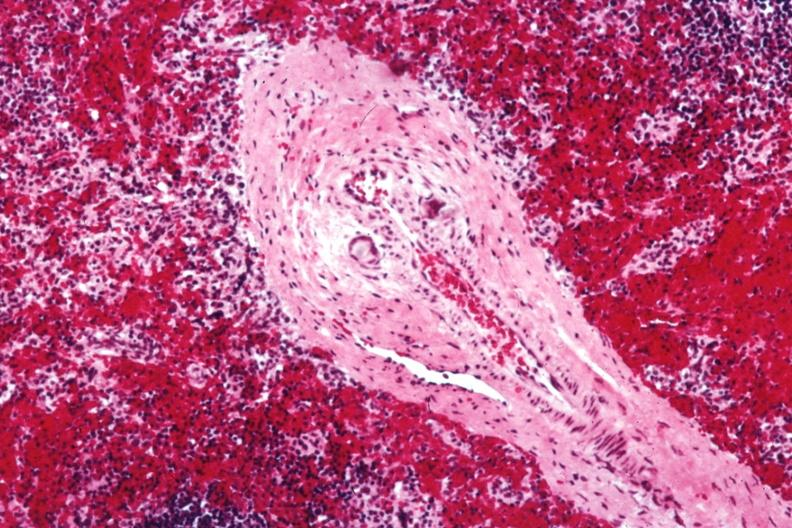what does this image show?
Answer the question using a single word or phrase. Med artery with giant cells in wall containing crystalline material postoperative cardiac surgery thought to be silicon 